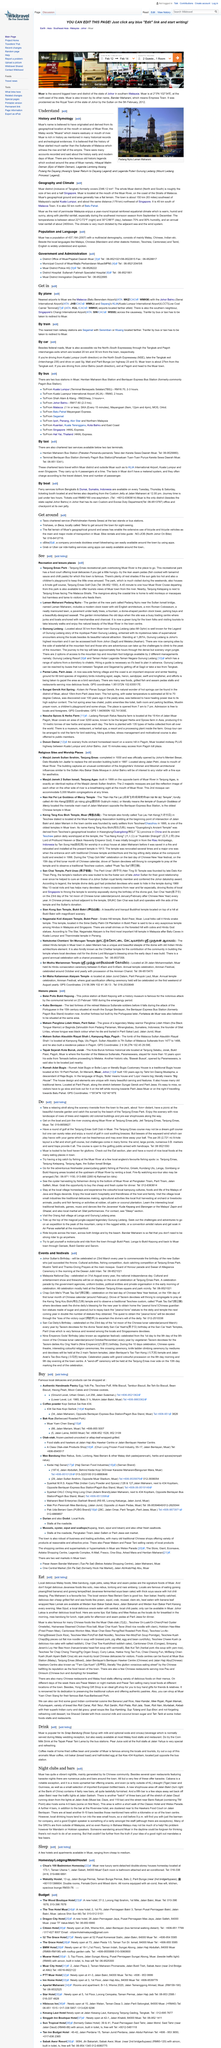Mention a couple of crucial points in this snapshot. Muar is a place that is rich in history. The history of Muar is believed to have started much earlier than the Sultanate of Malacca, according to historical records. Yes, readers should understand the history and etymology of Muar in order to gain a deeper appreciation and understanding of the place. 